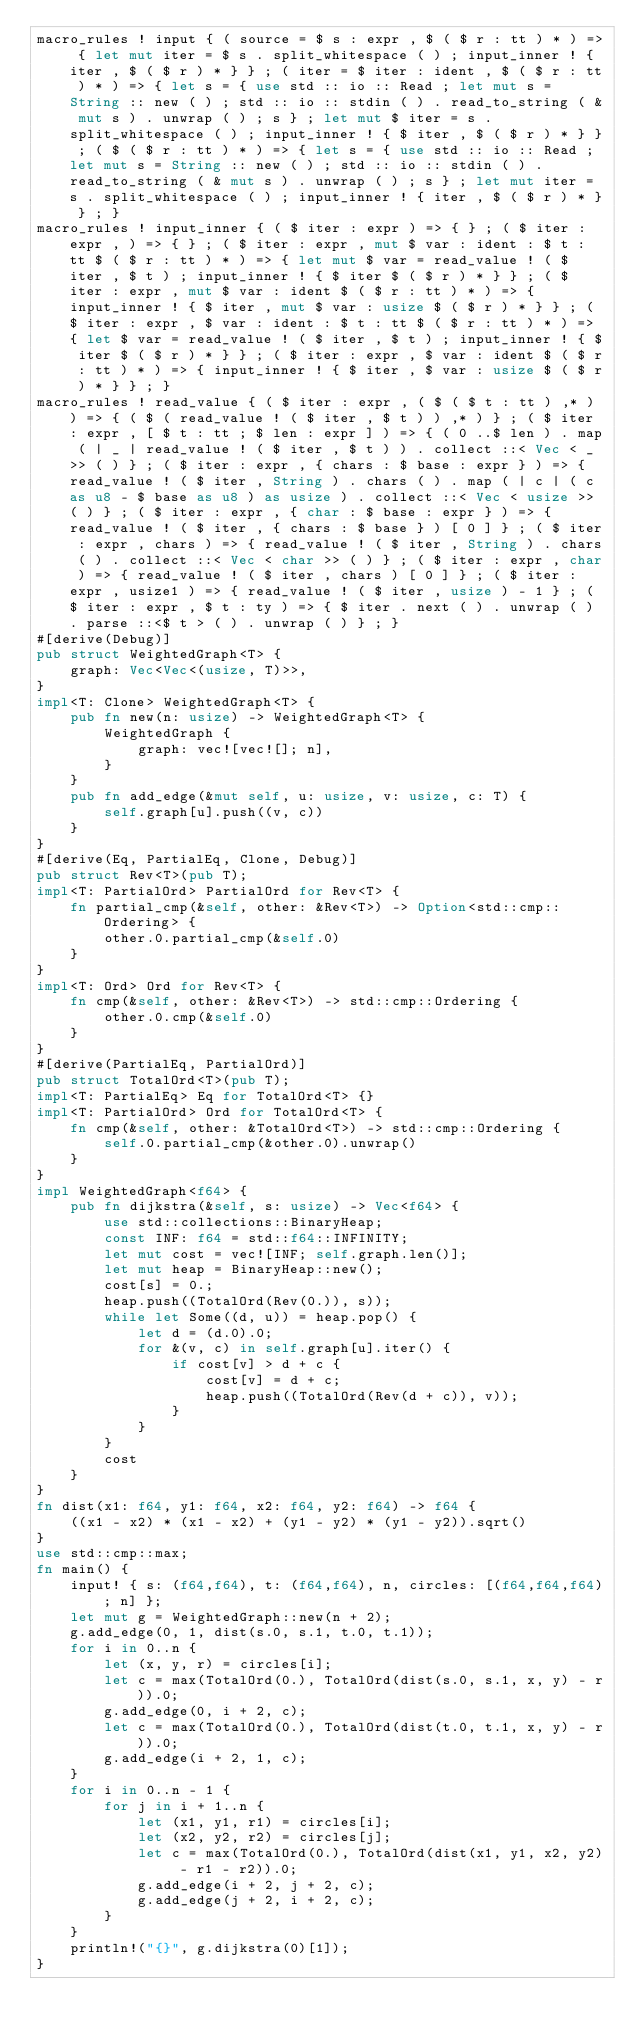Convert code to text. <code><loc_0><loc_0><loc_500><loc_500><_Rust_>macro_rules ! input { ( source = $ s : expr , $ ( $ r : tt ) * ) => { let mut iter = $ s . split_whitespace ( ) ; input_inner ! { iter , $ ( $ r ) * } } ; ( iter = $ iter : ident , $ ( $ r : tt ) * ) => { let s = { use std :: io :: Read ; let mut s = String :: new ( ) ; std :: io :: stdin ( ) . read_to_string ( & mut s ) . unwrap ( ) ; s } ; let mut $ iter = s . split_whitespace ( ) ; input_inner ! { $ iter , $ ( $ r ) * } } ; ( $ ( $ r : tt ) * ) => { let s = { use std :: io :: Read ; let mut s = String :: new ( ) ; std :: io :: stdin ( ) . read_to_string ( & mut s ) . unwrap ( ) ; s } ; let mut iter = s . split_whitespace ( ) ; input_inner ! { iter , $ ( $ r ) * } } ; }
macro_rules ! input_inner { ( $ iter : expr ) => { } ; ( $ iter : expr , ) => { } ; ( $ iter : expr , mut $ var : ident : $ t : tt $ ( $ r : tt ) * ) => { let mut $ var = read_value ! ( $ iter , $ t ) ; input_inner ! { $ iter $ ( $ r ) * } } ; ( $ iter : expr , mut $ var : ident $ ( $ r : tt ) * ) => { input_inner ! { $ iter , mut $ var : usize $ ( $ r ) * } } ; ( $ iter : expr , $ var : ident : $ t : tt $ ( $ r : tt ) * ) => { let $ var = read_value ! ( $ iter , $ t ) ; input_inner ! { $ iter $ ( $ r ) * } } ; ( $ iter : expr , $ var : ident $ ( $ r : tt ) * ) => { input_inner ! { $ iter , $ var : usize $ ( $ r ) * } } ; }
macro_rules ! read_value { ( $ iter : expr , ( $ ( $ t : tt ) ,* ) ) => { ( $ ( read_value ! ( $ iter , $ t ) ) ,* ) } ; ( $ iter : expr , [ $ t : tt ; $ len : expr ] ) => { ( 0 ..$ len ) . map ( | _ | read_value ! ( $ iter , $ t ) ) . collect ::< Vec < _ >> ( ) } ; ( $ iter : expr , { chars : $ base : expr } ) => { read_value ! ( $ iter , String ) . chars ( ) . map ( | c | ( c as u8 - $ base as u8 ) as usize ) . collect ::< Vec < usize >> ( ) } ; ( $ iter : expr , { char : $ base : expr } ) => { read_value ! ( $ iter , { chars : $ base } ) [ 0 ] } ; ( $ iter : expr , chars ) => { read_value ! ( $ iter , String ) . chars ( ) . collect ::< Vec < char >> ( ) } ; ( $ iter : expr , char ) => { read_value ! ( $ iter , chars ) [ 0 ] } ; ( $ iter : expr , usize1 ) => { read_value ! ( $ iter , usize ) - 1 } ; ( $ iter : expr , $ t : ty ) => { $ iter . next ( ) . unwrap ( ) . parse ::<$ t > ( ) . unwrap ( ) } ; }
#[derive(Debug)]
pub struct WeightedGraph<T> {
    graph: Vec<Vec<(usize, T)>>,
}
impl<T: Clone> WeightedGraph<T> {
    pub fn new(n: usize) -> WeightedGraph<T> {
        WeightedGraph {
            graph: vec![vec![]; n],
        }
    }
    pub fn add_edge(&mut self, u: usize, v: usize, c: T) {
        self.graph[u].push((v, c))
    }
}
#[derive(Eq, PartialEq, Clone, Debug)]
pub struct Rev<T>(pub T);
impl<T: PartialOrd> PartialOrd for Rev<T> {
    fn partial_cmp(&self, other: &Rev<T>) -> Option<std::cmp::Ordering> {
        other.0.partial_cmp(&self.0)
    }
}
impl<T: Ord> Ord for Rev<T> {
    fn cmp(&self, other: &Rev<T>) -> std::cmp::Ordering {
        other.0.cmp(&self.0)
    }
}
#[derive(PartialEq, PartialOrd)]
pub struct TotalOrd<T>(pub T);
impl<T: PartialEq> Eq for TotalOrd<T> {}
impl<T: PartialOrd> Ord for TotalOrd<T> {
    fn cmp(&self, other: &TotalOrd<T>) -> std::cmp::Ordering {
        self.0.partial_cmp(&other.0).unwrap()
    }
}
impl WeightedGraph<f64> {
    pub fn dijkstra(&self, s: usize) -> Vec<f64> {
        use std::collections::BinaryHeap;
        const INF: f64 = std::f64::INFINITY;
        let mut cost = vec![INF; self.graph.len()];
        let mut heap = BinaryHeap::new();
        cost[s] = 0.;
        heap.push((TotalOrd(Rev(0.)), s));
        while let Some((d, u)) = heap.pop() {
            let d = (d.0).0;
            for &(v, c) in self.graph[u].iter() {
                if cost[v] > d + c {
                    cost[v] = d + c;
                    heap.push((TotalOrd(Rev(d + c)), v));
                }
            }
        }
        cost
    }
}
fn dist(x1: f64, y1: f64, x2: f64, y2: f64) -> f64 {
    ((x1 - x2) * (x1 - x2) + (y1 - y2) * (y1 - y2)).sqrt()
}
use std::cmp::max;
fn main() {
    input! { s: (f64,f64), t: (f64,f64), n, circles: [(f64,f64,f64); n] };
    let mut g = WeightedGraph::new(n + 2);
    g.add_edge(0, 1, dist(s.0, s.1, t.0, t.1));
    for i in 0..n {
        let (x, y, r) = circles[i];
        let c = max(TotalOrd(0.), TotalOrd(dist(s.0, s.1, x, y) - r)).0;
        g.add_edge(0, i + 2, c);
        let c = max(TotalOrd(0.), TotalOrd(dist(t.0, t.1, x, y) - r)).0;
        g.add_edge(i + 2, 1, c);
    }
    for i in 0..n - 1 {
        for j in i + 1..n {
            let (x1, y1, r1) = circles[i];
            let (x2, y2, r2) = circles[j];
            let c = max(TotalOrd(0.), TotalOrd(dist(x1, y1, x2, y2) - r1 - r2)).0;
            g.add_edge(i + 2, j + 2, c);
            g.add_edge(j + 2, i + 2, c);
        }
    }
    println!("{}", g.dijkstra(0)[1]);
}
</code> 